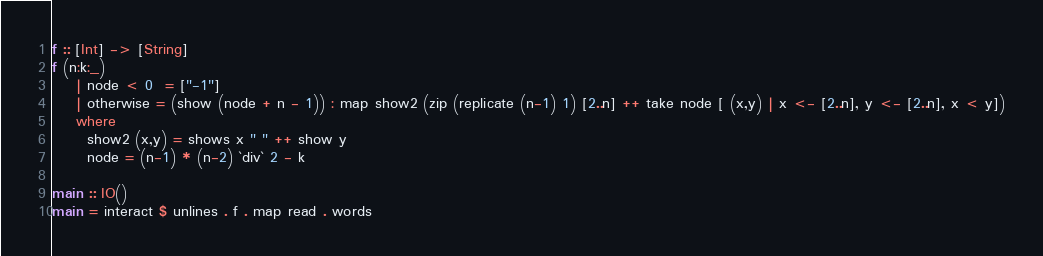<code> <loc_0><loc_0><loc_500><loc_500><_Haskell_>f :: [Int] -> [String]
f (n:k:_)
    | node < 0  = ["-1"]
    | otherwise = (show (node + n - 1)) : map show2 (zip (replicate (n-1) 1) [2..n] ++ take node [ (x,y) | x <- [2..n], y <- [2..n], x < y])
    where
      show2 (x,y) = shows x " " ++ show y
      node = (n-1) * (n-2) `div` 2 - k

main :: IO()
main = interact $ unlines . f . map read . words
</code> 